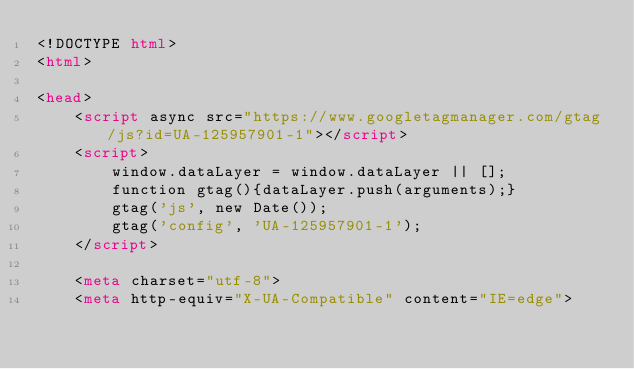Convert code to text. <code><loc_0><loc_0><loc_500><loc_500><_HTML_><!DOCTYPE html>
<html>

<head>
    <script async src="https://www.googletagmanager.com/gtag/js?id=UA-125957901-1"></script>
    <script>
        window.dataLayer = window.dataLayer || [];
        function gtag(){dataLayer.push(arguments);}
        gtag('js', new Date());
        gtag('config', 'UA-125957901-1');
    </script>

    <meta charset="utf-8">
    <meta http-equiv="X-UA-Compatible" content="IE=edge"></code> 